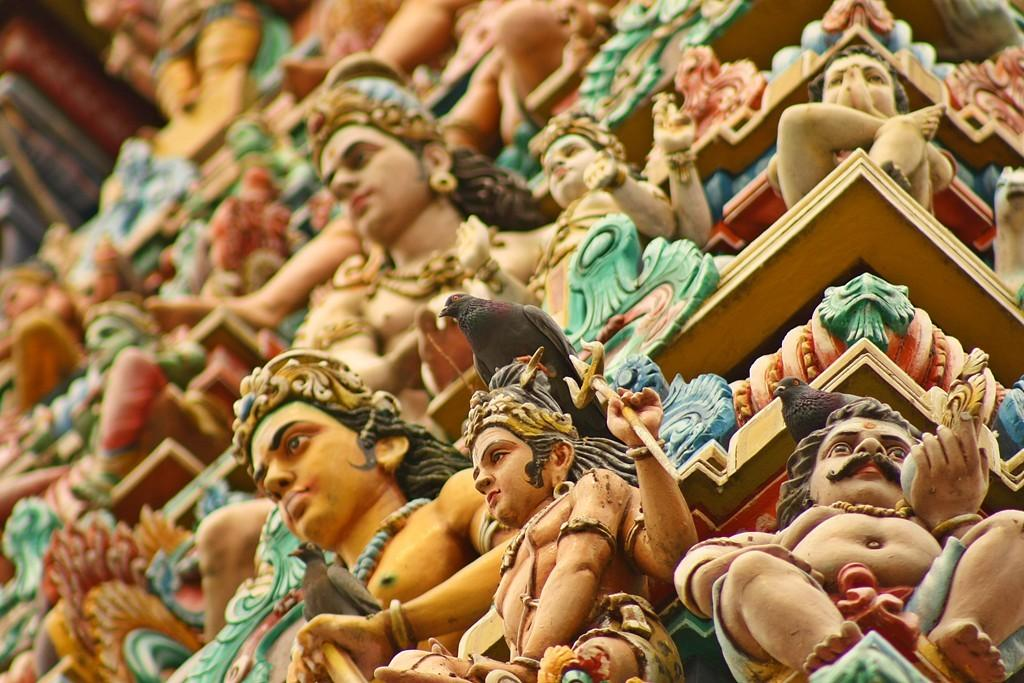What type of statue is present in the image? There is a religion colorful statue in the image. What other living creatures can be seen in the image? There are birds in the image. What type of camp can be seen in the image? There is no camp present in the image; it features a religion colorful statue and birds. How many bats are visible in the image? There are no bats visible in the image; it features a religion colorful statue and birds. 